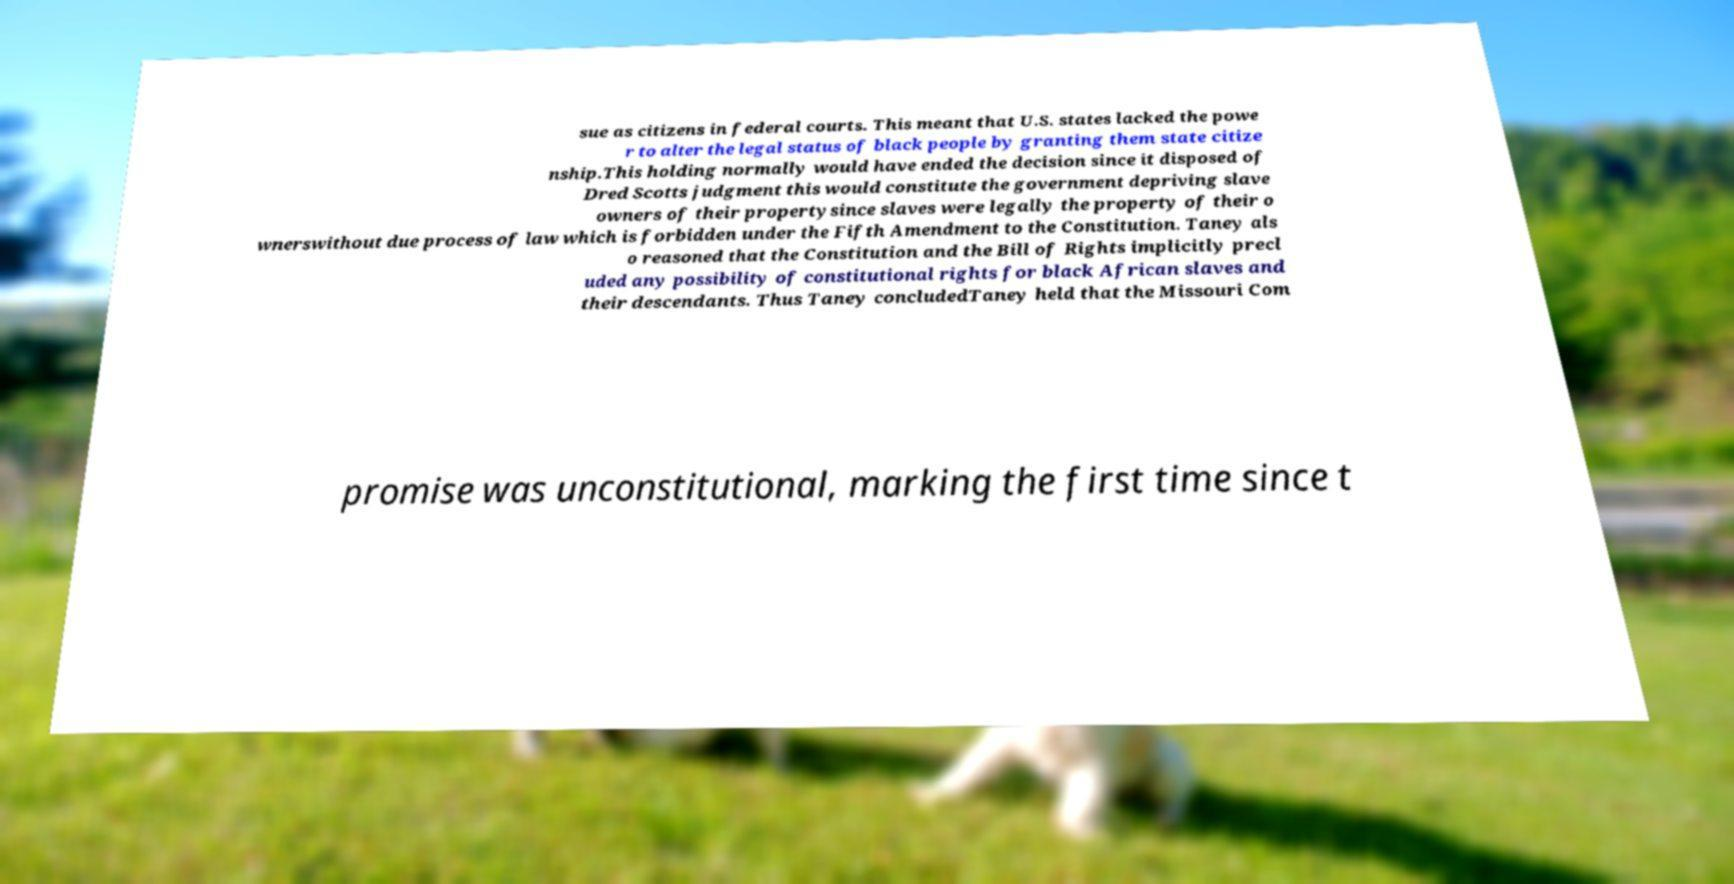What messages or text are displayed in this image? I need them in a readable, typed format. sue as citizens in federal courts. This meant that U.S. states lacked the powe r to alter the legal status of black people by granting them state citize nship.This holding normally would have ended the decision since it disposed of Dred Scotts judgment this would constitute the government depriving slave owners of their propertysince slaves were legally the property of their o wnerswithout due process of law which is forbidden under the Fifth Amendment to the Constitution. Taney als o reasoned that the Constitution and the Bill of Rights implicitly precl uded any possibility of constitutional rights for black African slaves and their descendants. Thus Taney concludedTaney held that the Missouri Com promise was unconstitutional, marking the first time since t 